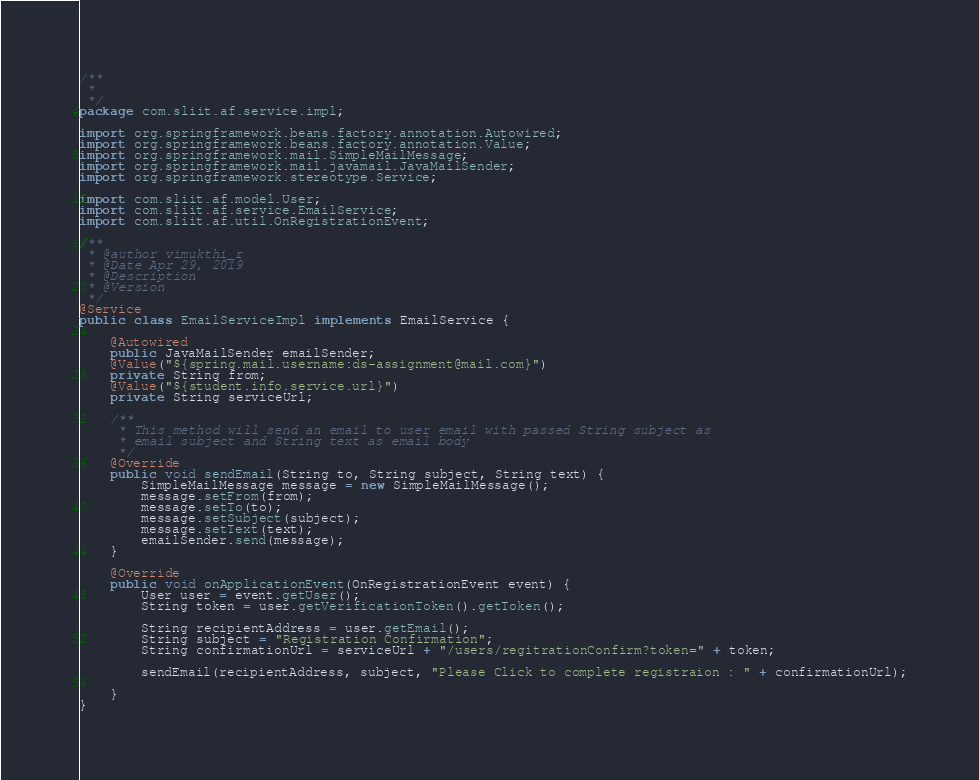Convert code to text. <code><loc_0><loc_0><loc_500><loc_500><_Java_>/**
 * 
 */
package com.sliit.af.service.impl;

import org.springframework.beans.factory.annotation.Autowired;
import org.springframework.beans.factory.annotation.Value;
import org.springframework.mail.SimpleMailMessage;
import org.springframework.mail.javamail.JavaMailSender;
import org.springframework.stereotype.Service;

import com.sliit.af.model.User;
import com.sliit.af.service.EmailService;
import com.sliit.af.util.OnRegistrationEvent;

/**
 * @author vimukthi_r
 * @Date Apr 29, 2019
 * @Description
 * @Version
 */
@Service
public class EmailServiceImpl implements EmailService {

	@Autowired
	public JavaMailSender emailSender;
	@Value("${spring.mail.username:ds-assignment@mail.com}")
	private String from;
	@Value("${student.info.service.url}")
	private String serviceUrl;

	/**
	 * This method will send an email to user email with passed String subject as
	 * email subject and String text as email body
	 */
	@Override
	public void sendEmail(String to, String subject, String text) {
		SimpleMailMessage message = new SimpleMailMessage();
		message.setFrom(from);
		message.setTo(to);
		message.setSubject(subject);
		message.setText(text);
		emailSender.send(message);
	}

	@Override
	public void onApplicationEvent(OnRegistrationEvent event) {
		User user = event.getUser();
		String token = user.getVerificationToken().getToken();

		String recipientAddress = user.getEmail();
		String subject = "Registration Confirmation";
		String confirmationUrl = serviceUrl + "/users/regitrationConfirm?token=" + token;

		sendEmail(recipientAddress, subject, "Please Click to complete registraion : " + confirmationUrl);

	}
}
</code> 